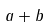<formula> <loc_0><loc_0><loc_500><loc_500>a + b</formula> 